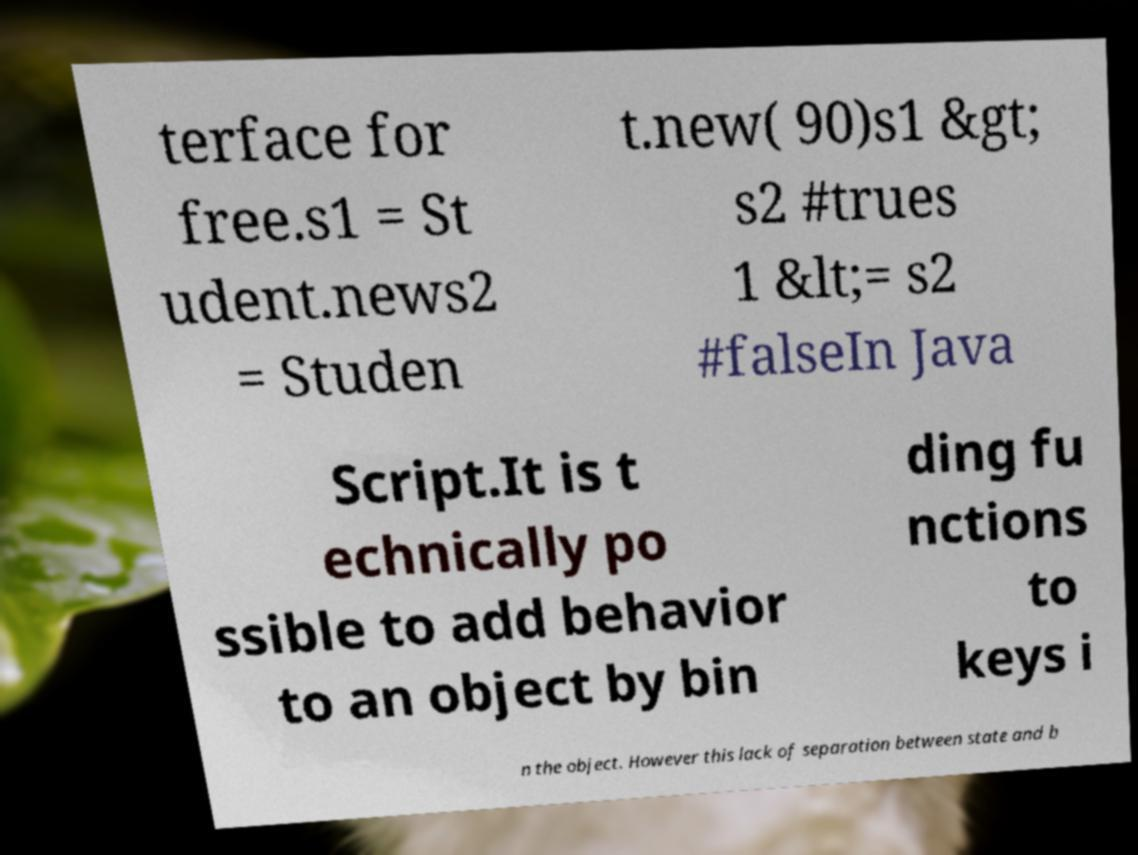Please identify and transcribe the text found in this image. terface for free.s1 = St udent.news2 = Studen t.new( 90)s1 &gt; s2 #trues 1 &lt;= s2 #falseIn Java Script.It is t echnically po ssible to add behavior to an object by bin ding fu nctions to keys i n the object. However this lack of separation between state and b 